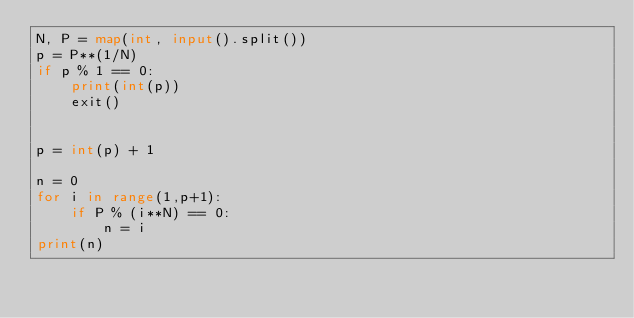Convert code to text. <code><loc_0><loc_0><loc_500><loc_500><_Python_>N, P = map(int, input().split())
p = P**(1/N)
if p % 1 == 0:
    print(int(p))
    exit()


p = int(p) + 1

n = 0
for i in range(1,p+1):
    if P % (i**N) == 0:
        n = i
print(n)</code> 